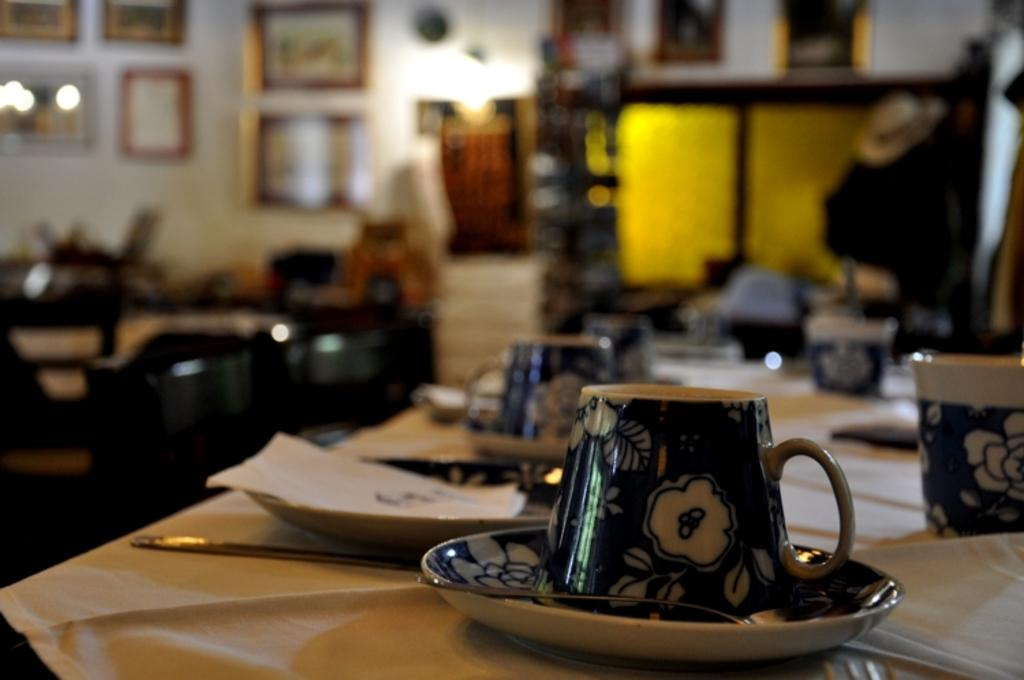What is the main piece of furniture in the image? There is a table in the image. What items are placed on the table? Tissues, plates, cups, and sauces are placed on the table. Are there any decorations or items on the wall in the background? Yes, there are photographs attached to the wall in the background of the image. How many cats are sitting on the table in the image? There are no cats present in the image. Is this a payment or billing area in the image? The image does not show any payment or billing area; it only shows a table with various items on it and photographs on the wall. 